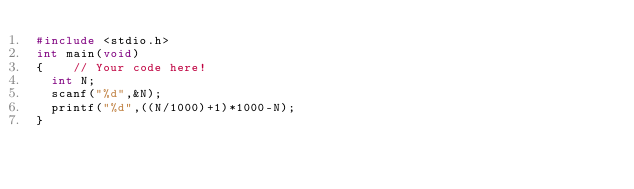<code> <loc_0><loc_0><loc_500><loc_500><_C_>#include <stdio.h>
int main(void)
{    // Your code here!
  int N;
  scanf("%d",&N);
  printf("%d",((N/1000)+1)*1000-N);
}
</code> 